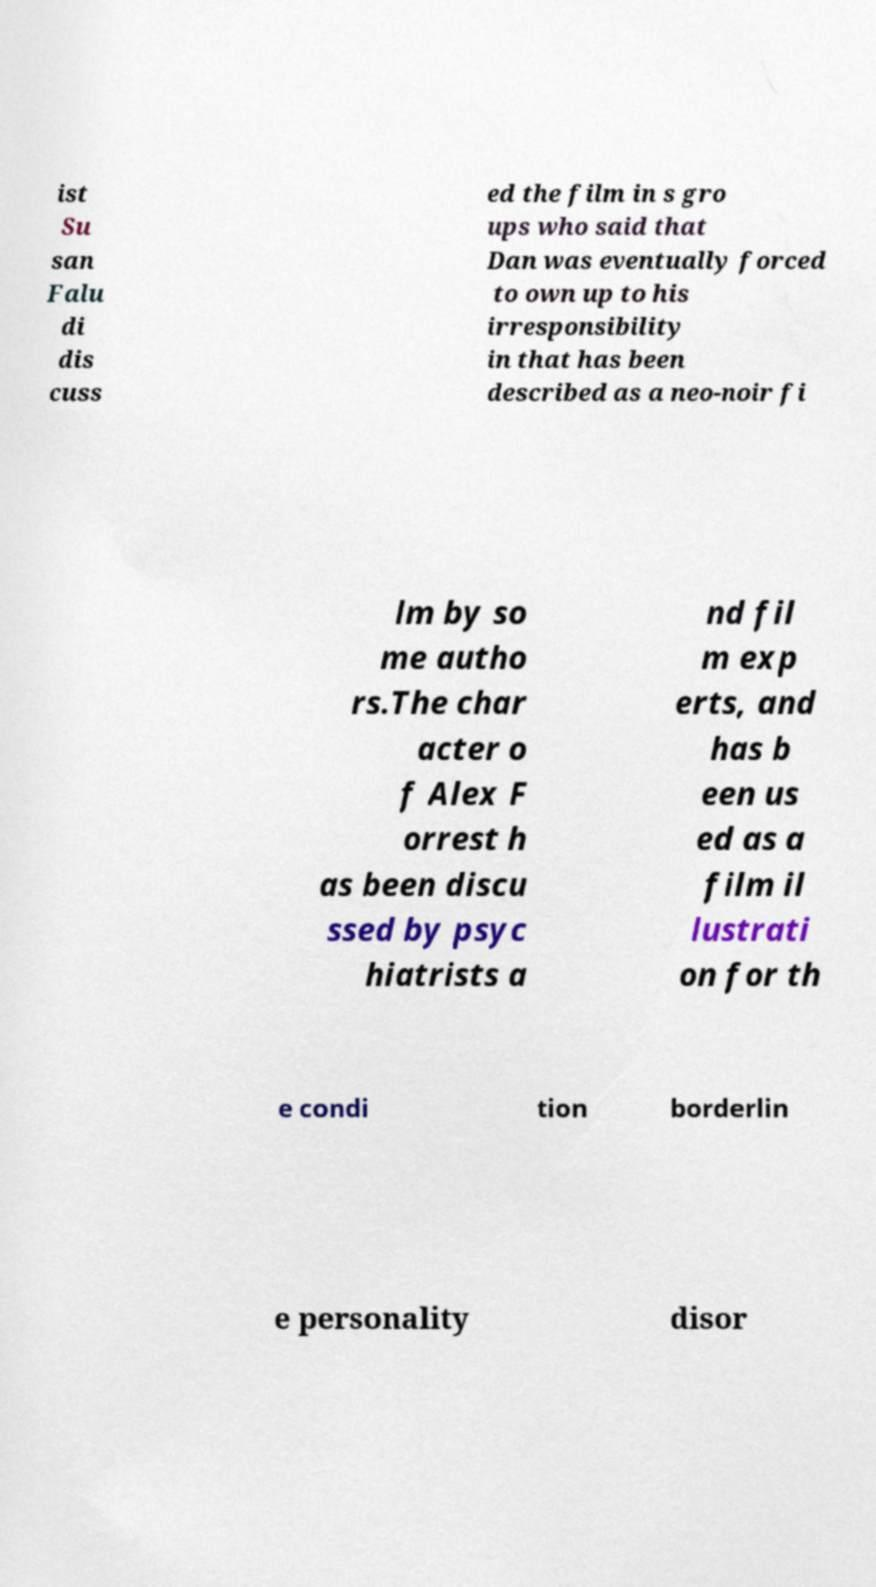What messages or text are displayed in this image? I need them in a readable, typed format. ist Su san Falu di dis cuss ed the film in s gro ups who said that Dan was eventually forced to own up to his irresponsibility in that has been described as a neo-noir fi lm by so me autho rs.The char acter o f Alex F orrest h as been discu ssed by psyc hiatrists a nd fil m exp erts, and has b een us ed as a film il lustrati on for th e condi tion borderlin e personality disor 